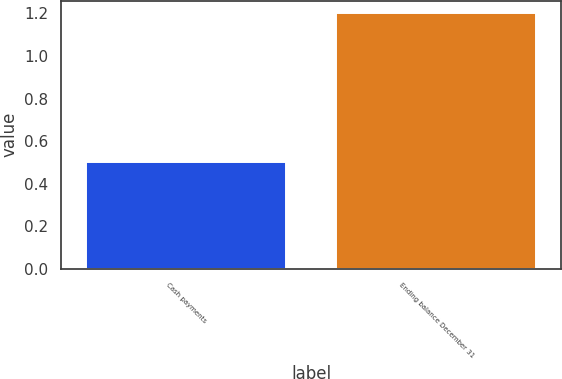<chart> <loc_0><loc_0><loc_500><loc_500><bar_chart><fcel>Cash payments<fcel>Ending balance December 31<nl><fcel>0.5<fcel>1.2<nl></chart> 